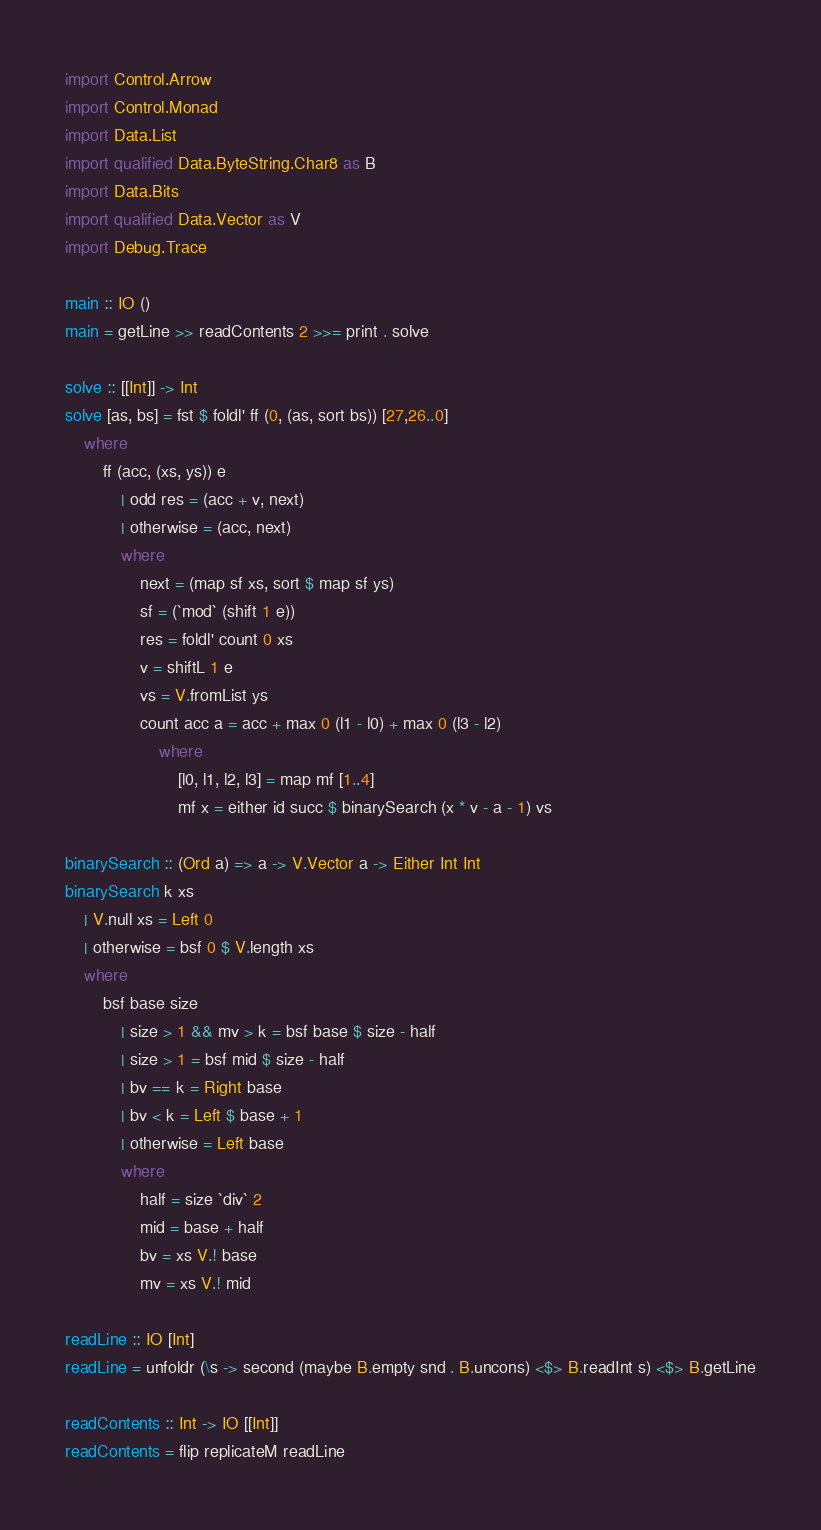<code> <loc_0><loc_0><loc_500><loc_500><_Haskell_>import Control.Arrow
import Control.Monad
import Data.List
import qualified Data.ByteString.Char8 as B
import Data.Bits
import qualified Data.Vector as V
import Debug.Trace

main :: IO ()
main = getLine >> readContents 2 >>= print . solve 

solve :: [[Int]] -> Int
solve [as, bs] = fst $ foldl' ff (0, (as, sort bs)) [27,26..0]
    where
        ff (acc, (xs, ys)) e
            | odd res = (acc + v, next)
            | otherwise = (acc, next)
            where
                next = (map sf xs, sort $ map sf ys)
                sf = (`mod` (shift 1 e))
                res = foldl' count 0 xs
                v = shiftL 1 e
                vs = V.fromList ys
                count acc a = acc + max 0 (l1 - l0) + max 0 (l3 - l2)
                    where
                        [l0, l1, l2, l3] = map mf [1..4]
                        mf x = either id succ $ binarySearch (x * v - a - 1) vs

binarySearch :: (Ord a) => a -> V.Vector a -> Either Int Int
binarySearch k xs
    | V.null xs = Left 0
    | otherwise = bsf 0 $ V.length xs
    where
        bsf base size
            | size > 1 && mv > k = bsf base $ size - half
            | size > 1 = bsf mid $ size - half
            | bv == k = Right base
            | bv < k = Left $ base + 1
            | otherwise = Left base
            where
                half = size `div` 2
                mid = base + half
                bv = xs V.! base
                mv = xs V.! mid

readLine :: IO [Int]
readLine = unfoldr (\s -> second (maybe B.empty snd . B.uncons) <$> B.readInt s) <$> B.getLine

readContents :: Int -> IO [[Int]]
readContents = flip replicateM readLine</code> 